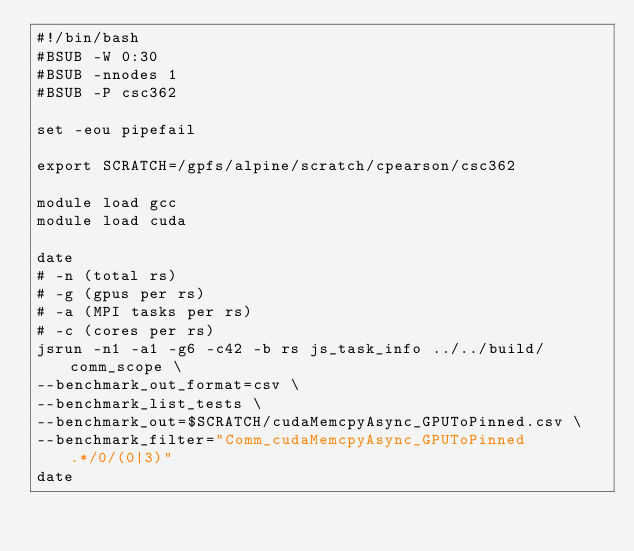<code> <loc_0><loc_0><loc_500><loc_500><_Bash_>#!/bin/bash
#BSUB -W 0:30
#BSUB -nnodes 1
#BSUB -P csc362

set -eou pipefail

export SCRATCH=/gpfs/alpine/scratch/cpearson/csc362

module load gcc
module load cuda

date
# -n (total rs)
# -g (gpus per rs)
# -a (MPI tasks per rs)
# -c (cores per rs)
jsrun -n1 -a1 -g6 -c42 -b rs js_task_info ../../build/comm_scope \
--benchmark_out_format=csv \
--benchmark_list_tests \
--benchmark_out=$SCRATCH/cudaMemcpyAsync_GPUToPinned.csv \
--benchmark_filter="Comm_cudaMemcpyAsync_GPUToPinned.*/0/(0|3)"
date
</code> 